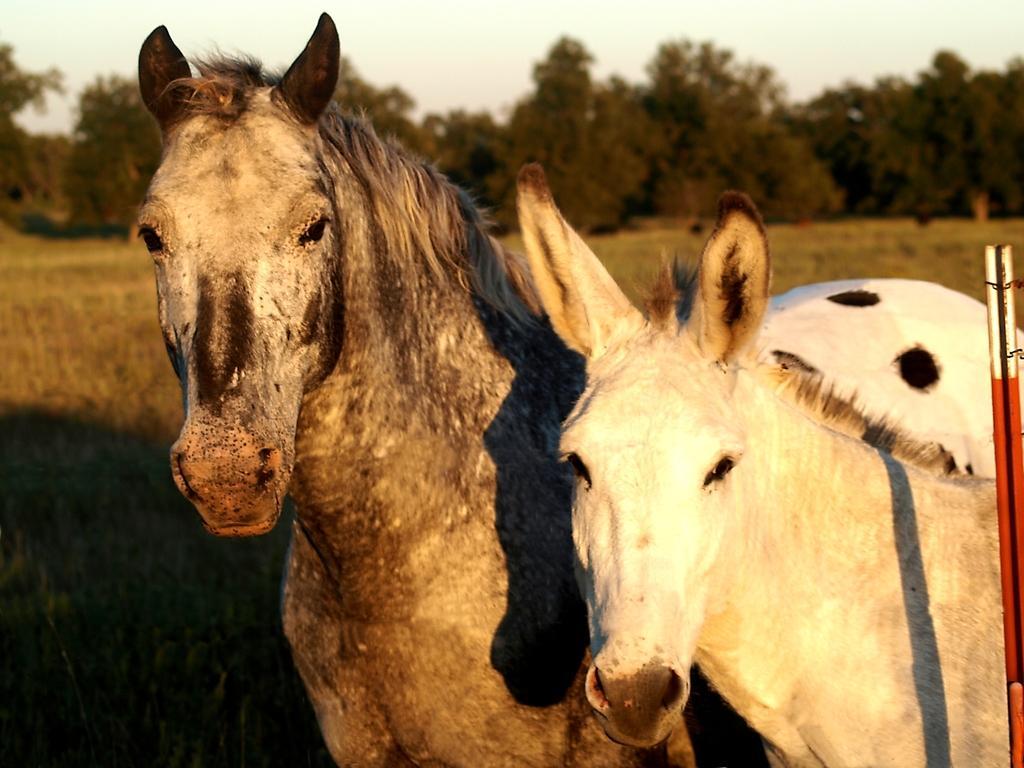In one or two sentences, can you explain what this image depicts? This is an outside view. Here I can see two animals. On the right side there is a metal rod. On the ground, I can see the grass. In the background there are some trees. At the top of the image I can see the sky. 